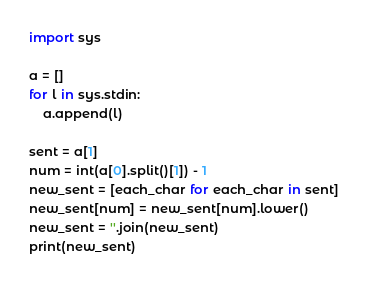<code> <loc_0><loc_0><loc_500><loc_500><_Python_>import sys

a = []
for l in sys.stdin:
    a.append(l)

sent = a[1]
num = int(a[0].split()[1]) - 1
new_sent = [each_char for each_char in sent]
new_sent[num] = new_sent[num].lower()
new_sent = ''.join(new_sent)
print(new_sent)
</code> 